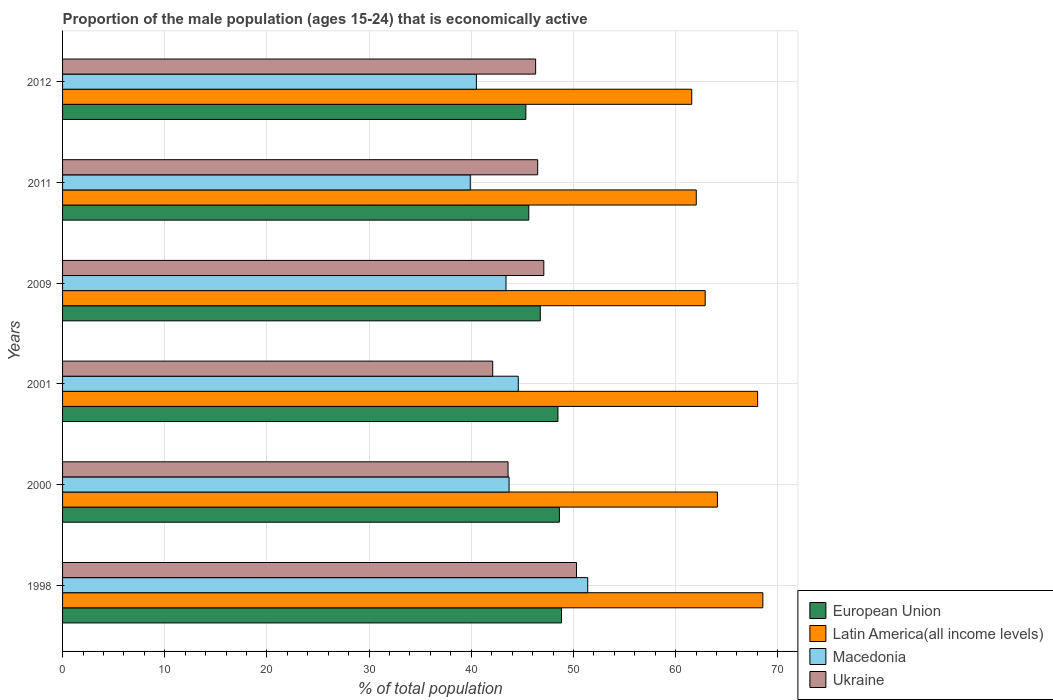How many different coloured bars are there?
Offer a terse response. 4. Are the number of bars per tick equal to the number of legend labels?
Make the answer very short. Yes. How many bars are there on the 4th tick from the top?
Provide a short and direct response. 4. What is the label of the 5th group of bars from the top?
Your response must be concise. 2000. What is the proportion of the male population that is economically active in European Union in 1998?
Ensure brevity in your answer.  48.83. Across all years, what is the maximum proportion of the male population that is economically active in European Union?
Your response must be concise. 48.83. Across all years, what is the minimum proportion of the male population that is economically active in European Union?
Offer a very short reply. 45.34. What is the total proportion of the male population that is economically active in Macedonia in the graph?
Ensure brevity in your answer.  263.5. What is the difference between the proportion of the male population that is economically active in Ukraine in 1998 and that in 2009?
Keep it short and to the point. 3.2. What is the difference between the proportion of the male population that is economically active in Ukraine in 2011 and the proportion of the male population that is economically active in Latin America(all income levels) in 2001?
Keep it short and to the point. -21.53. What is the average proportion of the male population that is economically active in Macedonia per year?
Ensure brevity in your answer.  43.92. In the year 2009, what is the difference between the proportion of the male population that is economically active in Latin America(all income levels) and proportion of the male population that is economically active in Macedonia?
Provide a short and direct response. 19.49. In how many years, is the proportion of the male population that is economically active in European Union greater than 16 %?
Provide a succinct answer. 6. What is the ratio of the proportion of the male population that is economically active in European Union in 2000 to that in 2012?
Give a very brief answer. 1.07. What is the difference between the highest and the second highest proportion of the male population that is economically active in Latin America(all income levels)?
Keep it short and to the point. 0.51. What is the difference between the highest and the lowest proportion of the male population that is economically active in Ukraine?
Offer a terse response. 8.2. In how many years, is the proportion of the male population that is economically active in Macedonia greater than the average proportion of the male population that is economically active in Macedonia taken over all years?
Offer a terse response. 2. Is the sum of the proportion of the male population that is economically active in Ukraine in 2011 and 2012 greater than the maximum proportion of the male population that is economically active in Latin America(all income levels) across all years?
Your answer should be compact. Yes. Is it the case that in every year, the sum of the proportion of the male population that is economically active in Latin America(all income levels) and proportion of the male population that is economically active in Macedonia is greater than the sum of proportion of the male population that is economically active in Ukraine and proportion of the male population that is economically active in European Union?
Make the answer very short. Yes. What does the 3rd bar from the top in 2011 represents?
Provide a succinct answer. Latin America(all income levels). What does the 3rd bar from the bottom in 2001 represents?
Provide a short and direct response. Macedonia. How many bars are there?
Provide a short and direct response. 24. Are all the bars in the graph horizontal?
Provide a succinct answer. Yes. How many years are there in the graph?
Offer a terse response. 6. Are the values on the major ticks of X-axis written in scientific E-notation?
Your response must be concise. No. Does the graph contain any zero values?
Your answer should be very brief. No. How are the legend labels stacked?
Offer a terse response. Vertical. What is the title of the graph?
Your answer should be compact. Proportion of the male population (ages 15-24) that is economically active. What is the label or title of the X-axis?
Offer a terse response. % of total population. What is the label or title of the Y-axis?
Keep it short and to the point. Years. What is the % of total population of European Union in 1998?
Offer a terse response. 48.83. What is the % of total population of Latin America(all income levels) in 1998?
Provide a short and direct response. 68.54. What is the % of total population in Macedonia in 1998?
Offer a terse response. 51.4. What is the % of total population in Ukraine in 1998?
Your answer should be very brief. 50.3. What is the % of total population of European Union in 2000?
Your answer should be very brief. 48.62. What is the % of total population of Latin America(all income levels) in 2000?
Offer a very short reply. 64.09. What is the % of total population of Macedonia in 2000?
Give a very brief answer. 43.7. What is the % of total population of Ukraine in 2000?
Ensure brevity in your answer.  43.6. What is the % of total population in European Union in 2001?
Your answer should be compact. 48.48. What is the % of total population of Latin America(all income levels) in 2001?
Your answer should be compact. 68.03. What is the % of total population of Macedonia in 2001?
Provide a short and direct response. 44.6. What is the % of total population in Ukraine in 2001?
Offer a very short reply. 42.1. What is the % of total population of European Union in 2009?
Your response must be concise. 46.75. What is the % of total population in Latin America(all income levels) in 2009?
Provide a short and direct response. 62.89. What is the % of total population in Macedonia in 2009?
Give a very brief answer. 43.4. What is the % of total population of Ukraine in 2009?
Provide a short and direct response. 47.1. What is the % of total population of European Union in 2011?
Your response must be concise. 45.63. What is the % of total population of Latin America(all income levels) in 2011?
Keep it short and to the point. 62.02. What is the % of total population of Macedonia in 2011?
Keep it short and to the point. 39.9. What is the % of total population of Ukraine in 2011?
Offer a very short reply. 46.5. What is the % of total population in European Union in 2012?
Give a very brief answer. 45.34. What is the % of total population in Latin America(all income levels) in 2012?
Your answer should be very brief. 61.58. What is the % of total population of Macedonia in 2012?
Provide a short and direct response. 40.5. What is the % of total population in Ukraine in 2012?
Provide a short and direct response. 46.3. Across all years, what is the maximum % of total population in European Union?
Offer a very short reply. 48.83. Across all years, what is the maximum % of total population of Latin America(all income levels)?
Your response must be concise. 68.54. Across all years, what is the maximum % of total population in Macedonia?
Offer a terse response. 51.4. Across all years, what is the maximum % of total population of Ukraine?
Offer a very short reply. 50.3. Across all years, what is the minimum % of total population in European Union?
Give a very brief answer. 45.34. Across all years, what is the minimum % of total population in Latin America(all income levels)?
Provide a short and direct response. 61.58. Across all years, what is the minimum % of total population of Macedonia?
Provide a succinct answer. 39.9. Across all years, what is the minimum % of total population of Ukraine?
Your response must be concise. 42.1. What is the total % of total population of European Union in the graph?
Offer a very short reply. 283.67. What is the total % of total population of Latin America(all income levels) in the graph?
Provide a short and direct response. 387.15. What is the total % of total population of Macedonia in the graph?
Ensure brevity in your answer.  263.5. What is the total % of total population of Ukraine in the graph?
Ensure brevity in your answer.  275.9. What is the difference between the % of total population in European Union in 1998 and that in 2000?
Make the answer very short. 0.21. What is the difference between the % of total population in Latin America(all income levels) in 1998 and that in 2000?
Ensure brevity in your answer.  4.45. What is the difference between the % of total population of Macedonia in 1998 and that in 2000?
Provide a succinct answer. 7.7. What is the difference between the % of total population in European Union in 1998 and that in 2001?
Provide a short and direct response. 0.35. What is the difference between the % of total population of Latin America(all income levels) in 1998 and that in 2001?
Ensure brevity in your answer.  0.51. What is the difference between the % of total population of European Union in 1998 and that in 2009?
Offer a terse response. 2.08. What is the difference between the % of total population in Latin America(all income levels) in 1998 and that in 2009?
Give a very brief answer. 5.64. What is the difference between the % of total population in Ukraine in 1998 and that in 2009?
Your answer should be very brief. 3.2. What is the difference between the % of total population of European Union in 1998 and that in 2011?
Your answer should be very brief. 3.2. What is the difference between the % of total population of Latin America(all income levels) in 1998 and that in 2011?
Offer a terse response. 6.52. What is the difference between the % of total population in Macedonia in 1998 and that in 2011?
Your answer should be very brief. 11.5. What is the difference between the % of total population of European Union in 1998 and that in 2012?
Provide a succinct answer. 3.49. What is the difference between the % of total population in Latin America(all income levels) in 1998 and that in 2012?
Offer a very short reply. 6.96. What is the difference between the % of total population of Macedonia in 1998 and that in 2012?
Give a very brief answer. 10.9. What is the difference between the % of total population of Ukraine in 1998 and that in 2012?
Offer a very short reply. 4. What is the difference between the % of total population in European Union in 2000 and that in 2001?
Offer a terse response. 0.14. What is the difference between the % of total population of Latin America(all income levels) in 2000 and that in 2001?
Your response must be concise. -3.93. What is the difference between the % of total population in European Union in 2000 and that in 2009?
Provide a succinct answer. 1.87. What is the difference between the % of total population in Latin America(all income levels) in 2000 and that in 2009?
Give a very brief answer. 1.2. What is the difference between the % of total population of European Union in 2000 and that in 2011?
Ensure brevity in your answer.  2.99. What is the difference between the % of total population of Latin America(all income levels) in 2000 and that in 2011?
Offer a very short reply. 2.07. What is the difference between the % of total population in Macedonia in 2000 and that in 2011?
Provide a short and direct response. 3.8. What is the difference between the % of total population in Ukraine in 2000 and that in 2011?
Offer a terse response. -2.9. What is the difference between the % of total population of European Union in 2000 and that in 2012?
Provide a succinct answer. 3.28. What is the difference between the % of total population in Latin America(all income levels) in 2000 and that in 2012?
Offer a very short reply. 2.51. What is the difference between the % of total population of Macedonia in 2000 and that in 2012?
Your answer should be compact. 3.2. What is the difference between the % of total population in Ukraine in 2000 and that in 2012?
Offer a very short reply. -2.7. What is the difference between the % of total population of European Union in 2001 and that in 2009?
Keep it short and to the point. 1.73. What is the difference between the % of total population in Latin America(all income levels) in 2001 and that in 2009?
Your response must be concise. 5.13. What is the difference between the % of total population in Ukraine in 2001 and that in 2009?
Provide a short and direct response. -5. What is the difference between the % of total population in European Union in 2001 and that in 2011?
Your response must be concise. 2.86. What is the difference between the % of total population of Latin America(all income levels) in 2001 and that in 2011?
Ensure brevity in your answer.  6. What is the difference between the % of total population in Macedonia in 2001 and that in 2011?
Offer a very short reply. 4.7. What is the difference between the % of total population of Ukraine in 2001 and that in 2011?
Make the answer very short. -4.4. What is the difference between the % of total population of European Union in 2001 and that in 2012?
Offer a terse response. 3.14. What is the difference between the % of total population in Latin America(all income levels) in 2001 and that in 2012?
Provide a short and direct response. 6.45. What is the difference between the % of total population in European Union in 2009 and that in 2011?
Give a very brief answer. 1.13. What is the difference between the % of total population in Latin America(all income levels) in 2009 and that in 2011?
Keep it short and to the point. 0.87. What is the difference between the % of total population in Ukraine in 2009 and that in 2011?
Keep it short and to the point. 0.6. What is the difference between the % of total population of European Union in 2009 and that in 2012?
Give a very brief answer. 1.41. What is the difference between the % of total population of Latin America(all income levels) in 2009 and that in 2012?
Provide a short and direct response. 1.31. What is the difference between the % of total population of Macedonia in 2009 and that in 2012?
Your response must be concise. 2.9. What is the difference between the % of total population of Ukraine in 2009 and that in 2012?
Give a very brief answer. 0.8. What is the difference between the % of total population of European Union in 2011 and that in 2012?
Your answer should be very brief. 0.29. What is the difference between the % of total population of Latin America(all income levels) in 2011 and that in 2012?
Offer a terse response. 0.44. What is the difference between the % of total population of Ukraine in 2011 and that in 2012?
Your answer should be compact. 0.2. What is the difference between the % of total population in European Union in 1998 and the % of total population in Latin America(all income levels) in 2000?
Give a very brief answer. -15.26. What is the difference between the % of total population in European Union in 1998 and the % of total population in Macedonia in 2000?
Offer a very short reply. 5.13. What is the difference between the % of total population of European Union in 1998 and the % of total population of Ukraine in 2000?
Your response must be concise. 5.23. What is the difference between the % of total population in Latin America(all income levels) in 1998 and the % of total population in Macedonia in 2000?
Provide a succinct answer. 24.84. What is the difference between the % of total population in Latin America(all income levels) in 1998 and the % of total population in Ukraine in 2000?
Your answer should be very brief. 24.94. What is the difference between the % of total population of European Union in 1998 and the % of total population of Latin America(all income levels) in 2001?
Offer a terse response. -19.19. What is the difference between the % of total population in European Union in 1998 and the % of total population in Macedonia in 2001?
Your answer should be very brief. 4.23. What is the difference between the % of total population of European Union in 1998 and the % of total population of Ukraine in 2001?
Provide a succinct answer. 6.73. What is the difference between the % of total population of Latin America(all income levels) in 1998 and the % of total population of Macedonia in 2001?
Provide a succinct answer. 23.94. What is the difference between the % of total population of Latin America(all income levels) in 1998 and the % of total population of Ukraine in 2001?
Your response must be concise. 26.44. What is the difference between the % of total population in Macedonia in 1998 and the % of total population in Ukraine in 2001?
Make the answer very short. 9.3. What is the difference between the % of total population in European Union in 1998 and the % of total population in Latin America(all income levels) in 2009?
Provide a succinct answer. -14.06. What is the difference between the % of total population in European Union in 1998 and the % of total population in Macedonia in 2009?
Your response must be concise. 5.43. What is the difference between the % of total population in European Union in 1998 and the % of total population in Ukraine in 2009?
Make the answer very short. 1.73. What is the difference between the % of total population in Latin America(all income levels) in 1998 and the % of total population in Macedonia in 2009?
Provide a short and direct response. 25.14. What is the difference between the % of total population in Latin America(all income levels) in 1998 and the % of total population in Ukraine in 2009?
Your response must be concise. 21.44. What is the difference between the % of total population in Macedonia in 1998 and the % of total population in Ukraine in 2009?
Ensure brevity in your answer.  4.3. What is the difference between the % of total population of European Union in 1998 and the % of total population of Latin America(all income levels) in 2011?
Offer a very short reply. -13.19. What is the difference between the % of total population in European Union in 1998 and the % of total population in Macedonia in 2011?
Provide a succinct answer. 8.93. What is the difference between the % of total population in European Union in 1998 and the % of total population in Ukraine in 2011?
Your answer should be compact. 2.33. What is the difference between the % of total population of Latin America(all income levels) in 1998 and the % of total population of Macedonia in 2011?
Offer a terse response. 28.64. What is the difference between the % of total population in Latin America(all income levels) in 1998 and the % of total population in Ukraine in 2011?
Provide a succinct answer. 22.04. What is the difference between the % of total population of European Union in 1998 and the % of total population of Latin America(all income levels) in 2012?
Your response must be concise. -12.75. What is the difference between the % of total population of European Union in 1998 and the % of total population of Macedonia in 2012?
Your response must be concise. 8.33. What is the difference between the % of total population of European Union in 1998 and the % of total population of Ukraine in 2012?
Make the answer very short. 2.53. What is the difference between the % of total population in Latin America(all income levels) in 1998 and the % of total population in Macedonia in 2012?
Your answer should be compact. 28.04. What is the difference between the % of total population in Latin America(all income levels) in 1998 and the % of total population in Ukraine in 2012?
Keep it short and to the point. 22.24. What is the difference between the % of total population in European Union in 2000 and the % of total population in Latin America(all income levels) in 2001?
Make the answer very short. -19.4. What is the difference between the % of total population of European Union in 2000 and the % of total population of Macedonia in 2001?
Offer a very short reply. 4.02. What is the difference between the % of total population in European Union in 2000 and the % of total population in Ukraine in 2001?
Offer a terse response. 6.52. What is the difference between the % of total population of Latin America(all income levels) in 2000 and the % of total population of Macedonia in 2001?
Give a very brief answer. 19.49. What is the difference between the % of total population of Latin America(all income levels) in 2000 and the % of total population of Ukraine in 2001?
Ensure brevity in your answer.  21.99. What is the difference between the % of total population of European Union in 2000 and the % of total population of Latin America(all income levels) in 2009?
Keep it short and to the point. -14.27. What is the difference between the % of total population in European Union in 2000 and the % of total population in Macedonia in 2009?
Provide a succinct answer. 5.22. What is the difference between the % of total population in European Union in 2000 and the % of total population in Ukraine in 2009?
Provide a short and direct response. 1.52. What is the difference between the % of total population in Latin America(all income levels) in 2000 and the % of total population in Macedonia in 2009?
Provide a succinct answer. 20.69. What is the difference between the % of total population in Latin America(all income levels) in 2000 and the % of total population in Ukraine in 2009?
Give a very brief answer. 16.99. What is the difference between the % of total population in Macedonia in 2000 and the % of total population in Ukraine in 2009?
Make the answer very short. -3.4. What is the difference between the % of total population of European Union in 2000 and the % of total population of Latin America(all income levels) in 2011?
Make the answer very short. -13.4. What is the difference between the % of total population of European Union in 2000 and the % of total population of Macedonia in 2011?
Your answer should be compact. 8.72. What is the difference between the % of total population of European Union in 2000 and the % of total population of Ukraine in 2011?
Your answer should be compact. 2.12. What is the difference between the % of total population of Latin America(all income levels) in 2000 and the % of total population of Macedonia in 2011?
Offer a terse response. 24.19. What is the difference between the % of total population in Latin America(all income levels) in 2000 and the % of total population in Ukraine in 2011?
Provide a short and direct response. 17.59. What is the difference between the % of total population in European Union in 2000 and the % of total population in Latin America(all income levels) in 2012?
Provide a succinct answer. -12.96. What is the difference between the % of total population of European Union in 2000 and the % of total population of Macedonia in 2012?
Provide a short and direct response. 8.12. What is the difference between the % of total population of European Union in 2000 and the % of total population of Ukraine in 2012?
Provide a succinct answer. 2.32. What is the difference between the % of total population of Latin America(all income levels) in 2000 and the % of total population of Macedonia in 2012?
Provide a short and direct response. 23.59. What is the difference between the % of total population in Latin America(all income levels) in 2000 and the % of total population in Ukraine in 2012?
Keep it short and to the point. 17.79. What is the difference between the % of total population in Macedonia in 2000 and the % of total population in Ukraine in 2012?
Ensure brevity in your answer.  -2.6. What is the difference between the % of total population in European Union in 2001 and the % of total population in Latin America(all income levels) in 2009?
Your response must be concise. -14.41. What is the difference between the % of total population in European Union in 2001 and the % of total population in Macedonia in 2009?
Ensure brevity in your answer.  5.08. What is the difference between the % of total population in European Union in 2001 and the % of total population in Ukraine in 2009?
Keep it short and to the point. 1.38. What is the difference between the % of total population of Latin America(all income levels) in 2001 and the % of total population of Macedonia in 2009?
Give a very brief answer. 24.63. What is the difference between the % of total population in Latin America(all income levels) in 2001 and the % of total population in Ukraine in 2009?
Ensure brevity in your answer.  20.93. What is the difference between the % of total population in Macedonia in 2001 and the % of total population in Ukraine in 2009?
Offer a very short reply. -2.5. What is the difference between the % of total population in European Union in 2001 and the % of total population in Latin America(all income levels) in 2011?
Give a very brief answer. -13.54. What is the difference between the % of total population of European Union in 2001 and the % of total population of Macedonia in 2011?
Offer a terse response. 8.58. What is the difference between the % of total population of European Union in 2001 and the % of total population of Ukraine in 2011?
Your answer should be compact. 1.98. What is the difference between the % of total population of Latin America(all income levels) in 2001 and the % of total population of Macedonia in 2011?
Offer a very short reply. 28.13. What is the difference between the % of total population of Latin America(all income levels) in 2001 and the % of total population of Ukraine in 2011?
Your response must be concise. 21.53. What is the difference between the % of total population in European Union in 2001 and the % of total population in Latin America(all income levels) in 2012?
Provide a short and direct response. -13.09. What is the difference between the % of total population in European Union in 2001 and the % of total population in Macedonia in 2012?
Your response must be concise. 7.98. What is the difference between the % of total population in European Union in 2001 and the % of total population in Ukraine in 2012?
Your response must be concise. 2.18. What is the difference between the % of total population in Latin America(all income levels) in 2001 and the % of total population in Macedonia in 2012?
Make the answer very short. 27.53. What is the difference between the % of total population in Latin America(all income levels) in 2001 and the % of total population in Ukraine in 2012?
Make the answer very short. 21.73. What is the difference between the % of total population of Macedonia in 2001 and the % of total population of Ukraine in 2012?
Your response must be concise. -1.7. What is the difference between the % of total population in European Union in 2009 and the % of total population in Latin America(all income levels) in 2011?
Ensure brevity in your answer.  -15.27. What is the difference between the % of total population in European Union in 2009 and the % of total population in Macedonia in 2011?
Your answer should be compact. 6.85. What is the difference between the % of total population of European Union in 2009 and the % of total population of Ukraine in 2011?
Offer a very short reply. 0.25. What is the difference between the % of total population in Latin America(all income levels) in 2009 and the % of total population in Macedonia in 2011?
Your answer should be very brief. 22.99. What is the difference between the % of total population of Latin America(all income levels) in 2009 and the % of total population of Ukraine in 2011?
Your answer should be compact. 16.39. What is the difference between the % of total population in European Union in 2009 and the % of total population in Latin America(all income levels) in 2012?
Offer a terse response. -14.82. What is the difference between the % of total population of European Union in 2009 and the % of total population of Macedonia in 2012?
Offer a terse response. 6.25. What is the difference between the % of total population of European Union in 2009 and the % of total population of Ukraine in 2012?
Provide a succinct answer. 0.45. What is the difference between the % of total population in Latin America(all income levels) in 2009 and the % of total population in Macedonia in 2012?
Your response must be concise. 22.39. What is the difference between the % of total population of Latin America(all income levels) in 2009 and the % of total population of Ukraine in 2012?
Ensure brevity in your answer.  16.59. What is the difference between the % of total population of Macedonia in 2009 and the % of total population of Ukraine in 2012?
Provide a succinct answer. -2.9. What is the difference between the % of total population in European Union in 2011 and the % of total population in Latin America(all income levels) in 2012?
Keep it short and to the point. -15.95. What is the difference between the % of total population in European Union in 2011 and the % of total population in Macedonia in 2012?
Provide a short and direct response. 5.13. What is the difference between the % of total population in European Union in 2011 and the % of total population in Ukraine in 2012?
Your answer should be very brief. -0.67. What is the difference between the % of total population in Latin America(all income levels) in 2011 and the % of total population in Macedonia in 2012?
Give a very brief answer. 21.52. What is the difference between the % of total population in Latin America(all income levels) in 2011 and the % of total population in Ukraine in 2012?
Offer a very short reply. 15.72. What is the average % of total population in European Union per year?
Offer a very short reply. 47.28. What is the average % of total population in Latin America(all income levels) per year?
Give a very brief answer. 64.52. What is the average % of total population in Macedonia per year?
Keep it short and to the point. 43.92. What is the average % of total population in Ukraine per year?
Give a very brief answer. 45.98. In the year 1998, what is the difference between the % of total population of European Union and % of total population of Latin America(all income levels)?
Make the answer very short. -19.71. In the year 1998, what is the difference between the % of total population of European Union and % of total population of Macedonia?
Provide a succinct answer. -2.57. In the year 1998, what is the difference between the % of total population in European Union and % of total population in Ukraine?
Your answer should be very brief. -1.47. In the year 1998, what is the difference between the % of total population of Latin America(all income levels) and % of total population of Macedonia?
Ensure brevity in your answer.  17.14. In the year 1998, what is the difference between the % of total population of Latin America(all income levels) and % of total population of Ukraine?
Your response must be concise. 18.24. In the year 2000, what is the difference between the % of total population of European Union and % of total population of Latin America(all income levels)?
Give a very brief answer. -15.47. In the year 2000, what is the difference between the % of total population of European Union and % of total population of Macedonia?
Provide a short and direct response. 4.92. In the year 2000, what is the difference between the % of total population in European Union and % of total population in Ukraine?
Ensure brevity in your answer.  5.02. In the year 2000, what is the difference between the % of total population of Latin America(all income levels) and % of total population of Macedonia?
Your answer should be compact. 20.39. In the year 2000, what is the difference between the % of total population in Latin America(all income levels) and % of total population in Ukraine?
Your answer should be compact. 20.49. In the year 2001, what is the difference between the % of total population in European Union and % of total population in Latin America(all income levels)?
Your answer should be very brief. -19.54. In the year 2001, what is the difference between the % of total population of European Union and % of total population of Macedonia?
Offer a terse response. 3.88. In the year 2001, what is the difference between the % of total population of European Union and % of total population of Ukraine?
Your answer should be very brief. 6.38. In the year 2001, what is the difference between the % of total population of Latin America(all income levels) and % of total population of Macedonia?
Make the answer very short. 23.43. In the year 2001, what is the difference between the % of total population of Latin America(all income levels) and % of total population of Ukraine?
Your answer should be very brief. 25.93. In the year 2009, what is the difference between the % of total population in European Union and % of total population in Latin America(all income levels)?
Provide a short and direct response. -16.14. In the year 2009, what is the difference between the % of total population in European Union and % of total population in Macedonia?
Your answer should be very brief. 3.35. In the year 2009, what is the difference between the % of total population of European Union and % of total population of Ukraine?
Your answer should be compact. -0.35. In the year 2009, what is the difference between the % of total population of Latin America(all income levels) and % of total population of Macedonia?
Your response must be concise. 19.49. In the year 2009, what is the difference between the % of total population in Latin America(all income levels) and % of total population in Ukraine?
Give a very brief answer. 15.79. In the year 2009, what is the difference between the % of total population in Macedonia and % of total population in Ukraine?
Your answer should be very brief. -3.7. In the year 2011, what is the difference between the % of total population of European Union and % of total population of Latin America(all income levels)?
Make the answer very short. -16.39. In the year 2011, what is the difference between the % of total population of European Union and % of total population of Macedonia?
Your answer should be compact. 5.73. In the year 2011, what is the difference between the % of total population of European Union and % of total population of Ukraine?
Ensure brevity in your answer.  -0.87. In the year 2011, what is the difference between the % of total population in Latin America(all income levels) and % of total population in Macedonia?
Your answer should be very brief. 22.12. In the year 2011, what is the difference between the % of total population in Latin America(all income levels) and % of total population in Ukraine?
Give a very brief answer. 15.52. In the year 2012, what is the difference between the % of total population of European Union and % of total population of Latin America(all income levels)?
Provide a short and direct response. -16.24. In the year 2012, what is the difference between the % of total population in European Union and % of total population in Macedonia?
Keep it short and to the point. 4.84. In the year 2012, what is the difference between the % of total population in European Union and % of total population in Ukraine?
Make the answer very short. -0.96. In the year 2012, what is the difference between the % of total population of Latin America(all income levels) and % of total population of Macedonia?
Keep it short and to the point. 21.08. In the year 2012, what is the difference between the % of total population in Latin America(all income levels) and % of total population in Ukraine?
Your answer should be very brief. 15.28. In the year 2012, what is the difference between the % of total population of Macedonia and % of total population of Ukraine?
Your answer should be compact. -5.8. What is the ratio of the % of total population of Latin America(all income levels) in 1998 to that in 2000?
Offer a terse response. 1.07. What is the ratio of the % of total population in Macedonia in 1998 to that in 2000?
Your response must be concise. 1.18. What is the ratio of the % of total population in Ukraine in 1998 to that in 2000?
Make the answer very short. 1.15. What is the ratio of the % of total population of European Union in 1998 to that in 2001?
Your response must be concise. 1.01. What is the ratio of the % of total population of Latin America(all income levels) in 1998 to that in 2001?
Your answer should be very brief. 1.01. What is the ratio of the % of total population in Macedonia in 1998 to that in 2001?
Ensure brevity in your answer.  1.15. What is the ratio of the % of total population in Ukraine in 1998 to that in 2001?
Your response must be concise. 1.19. What is the ratio of the % of total population of European Union in 1998 to that in 2009?
Offer a terse response. 1.04. What is the ratio of the % of total population of Latin America(all income levels) in 1998 to that in 2009?
Your answer should be very brief. 1.09. What is the ratio of the % of total population in Macedonia in 1998 to that in 2009?
Provide a succinct answer. 1.18. What is the ratio of the % of total population in Ukraine in 1998 to that in 2009?
Give a very brief answer. 1.07. What is the ratio of the % of total population in European Union in 1998 to that in 2011?
Your answer should be compact. 1.07. What is the ratio of the % of total population of Latin America(all income levels) in 1998 to that in 2011?
Offer a terse response. 1.11. What is the ratio of the % of total population of Macedonia in 1998 to that in 2011?
Make the answer very short. 1.29. What is the ratio of the % of total population of Ukraine in 1998 to that in 2011?
Keep it short and to the point. 1.08. What is the ratio of the % of total population of Latin America(all income levels) in 1998 to that in 2012?
Provide a short and direct response. 1.11. What is the ratio of the % of total population of Macedonia in 1998 to that in 2012?
Make the answer very short. 1.27. What is the ratio of the % of total population of Ukraine in 1998 to that in 2012?
Give a very brief answer. 1.09. What is the ratio of the % of total population in Latin America(all income levels) in 2000 to that in 2001?
Give a very brief answer. 0.94. What is the ratio of the % of total population in Macedonia in 2000 to that in 2001?
Offer a terse response. 0.98. What is the ratio of the % of total population in Ukraine in 2000 to that in 2001?
Offer a terse response. 1.04. What is the ratio of the % of total population of Latin America(all income levels) in 2000 to that in 2009?
Your answer should be very brief. 1.02. What is the ratio of the % of total population in Macedonia in 2000 to that in 2009?
Provide a short and direct response. 1.01. What is the ratio of the % of total population of Ukraine in 2000 to that in 2009?
Ensure brevity in your answer.  0.93. What is the ratio of the % of total population in European Union in 2000 to that in 2011?
Offer a terse response. 1.07. What is the ratio of the % of total population in Latin America(all income levels) in 2000 to that in 2011?
Your response must be concise. 1.03. What is the ratio of the % of total population in Macedonia in 2000 to that in 2011?
Ensure brevity in your answer.  1.1. What is the ratio of the % of total population of Ukraine in 2000 to that in 2011?
Provide a succinct answer. 0.94. What is the ratio of the % of total population of European Union in 2000 to that in 2012?
Your answer should be compact. 1.07. What is the ratio of the % of total population in Latin America(all income levels) in 2000 to that in 2012?
Give a very brief answer. 1.04. What is the ratio of the % of total population in Macedonia in 2000 to that in 2012?
Offer a very short reply. 1.08. What is the ratio of the % of total population in Ukraine in 2000 to that in 2012?
Offer a very short reply. 0.94. What is the ratio of the % of total population of Latin America(all income levels) in 2001 to that in 2009?
Ensure brevity in your answer.  1.08. What is the ratio of the % of total population in Macedonia in 2001 to that in 2009?
Provide a succinct answer. 1.03. What is the ratio of the % of total population of Ukraine in 2001 to that in 2009?
Give a very brief answer. 0.89. What is the ratio of the % of total population in European Union in 2001 to that in 2011?
Your answer should be very brief. 1.06. What is the ratio of the % of total population of Latin America(all income levels) in 2001 to that in 2011?
Ensure brevity in your answer.  1.1. What is the ratio of the % of total population in Macedonia in 2001 to that in 2011?
Keep it short and to the point. 1.12. What is the ratio of the % of total population of Ukraine in 2001 to that in 2011?
Give a very brief answer. 0.91. What is the ratio of the % of total population of European Union in 2001 to that in 2012?
Keep it short and to the point. 1.07. What is the ratio of the % of total population in Latin America(all income levels) in 2001 to that in 2012?
Offer a very short reply. 1.1. What is the ratio of the % of total population in Macedonia in 2001 to that in 2012?
Provide a succinct answer. 1.1. What is the ratio of the % of total population in Ukraine in 2001 to that in 2012?
Offer a terse response. 0.91. What is the ratio of the % of total population of European Union in 2009 to that in 2011?
Your answer should be compact. 1.02. What is the ratio of the % of total population of Latin America(all income levels) in 2009 to that in 2011?
Your response must be concise. 1.01. What is the ratio of the % of total population of Macedonia in 2009 to that in 2011?
Offer a terse response. 1.09. What is the ratio of the % of total population of Ukraine in 2009 to that in 2011?
Provide a short and direct response. 1.01. What is the ratio of the % of total population of European Union in 2009 to that in 2012?
Offer a very short reply. 1.03. What is the ratio of the % of total population of Latin America(all income levels) in 2009 to that in 2012?
Your response must be concise. 1.02. What is the ratio of the % of total population of Macedonia in 2009 to that in 2012?
Your answer should be very brief. 1.07. What is the ratio of the % of total population in Ukraine in 2009 to that in 2012?
Your answer should be very brief. 1.02. What is the ratio of the % of total population of European Union in 2011 to that in 2012?
Provide a short and direct response. 1.01. What is the ratio of the % of total population in Latin America(all income levels) in 2011 to that in 2012?
Keep it short and to the point. 1.01. What is the ratio of the % of total population in Macedonia in 2011 to that in 2012?
Offer a very short reply. 0.99. What is the difference between the highest and the second highest % of total population of European Union?
Offer a very short reply. 0.21. What is the difference between the highest and the second highest % of total population in Latin America(all income levels)?
Ensure brevity in your answer.  0.51. What is the difference between the highest and the second highest % of total population in Macedonia?
Provide a short and direct response. 6.8. What is the difference between the highest and the second highest % of total population in Ukraine?
Give a very brief answer. 3.2. What is the difference between the highest and the lowest % of total population in European Union?
Ensure brevity in your answer.  3.49. What is the difference between the highest and the lowest % of total population of Latin America(all income levels)?
Provide a short and direct response. 6.96. What is the difference between the highest and the lowest % of total population of Macedonia?
Provide a succinct answer. 11.5. What is the difference between the highest and the lowest % of total population in Ukraine?
Offer a very short reply. 8.2. 